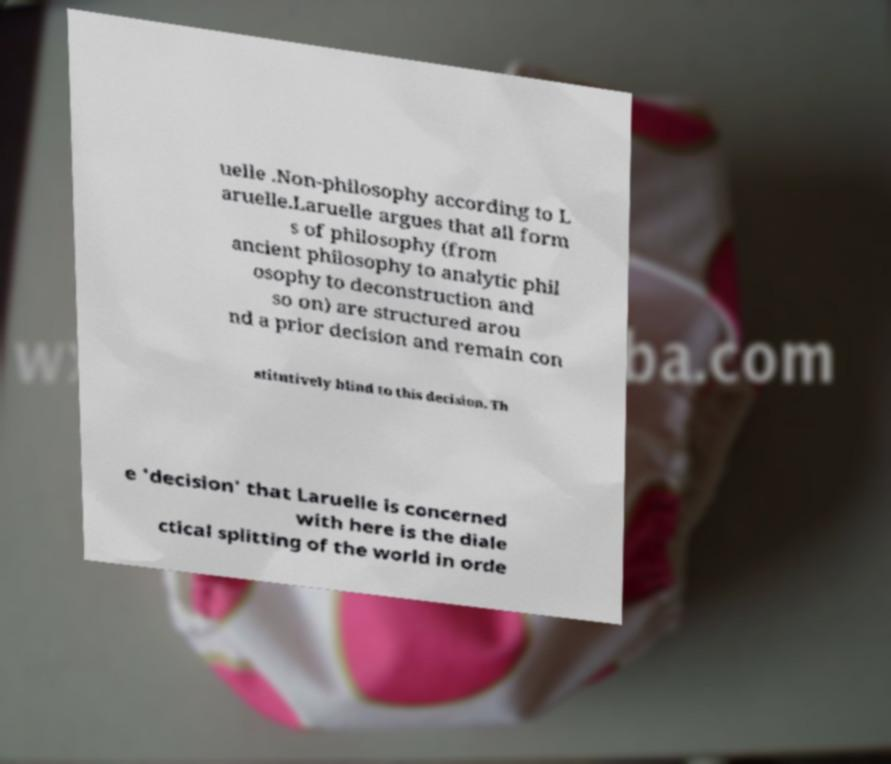Please identify and transcribe the text found in this image. uelle .Non-philosophy according to L aruelle.Laruelle argues that all form s of philosophy (from ancient philosophy to analytic phil osophy to deconstruction and so on) are structured arou nd a prior decision and remain con stitutively blind to this decision. Th e 'decision' that Laruelle is concerned with here is the diale ctical splitting of the world in orde 